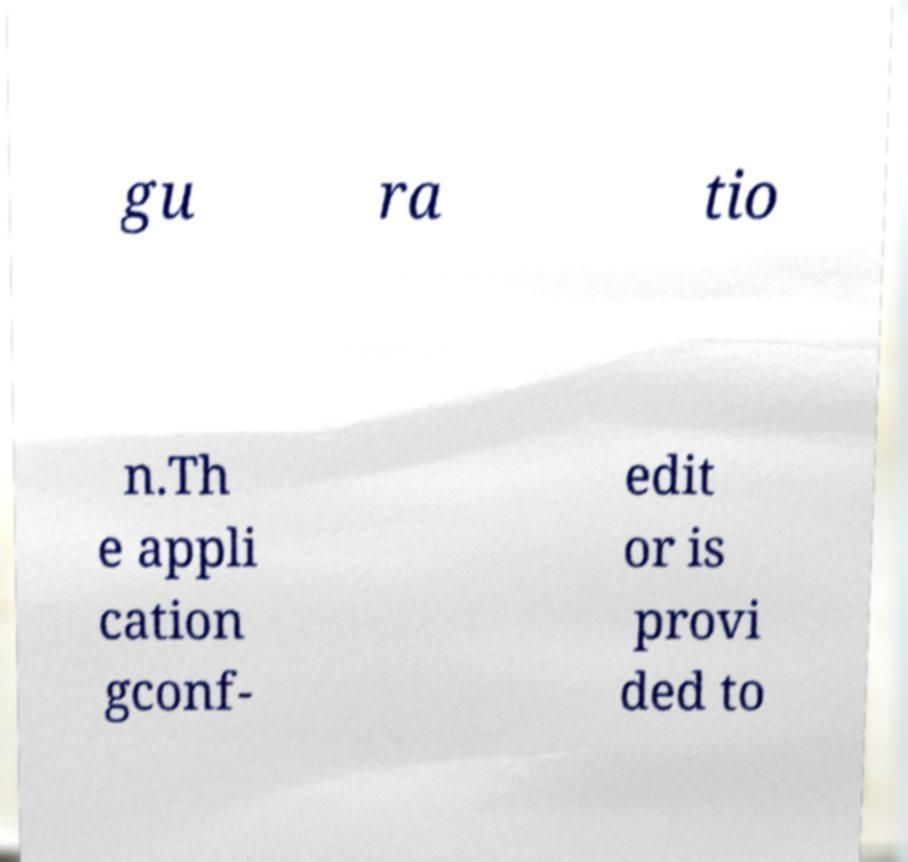Please identify and transcribe the text found in this image. gu ra tio n.Th e appli cation gconf- edit or is provi ded to 